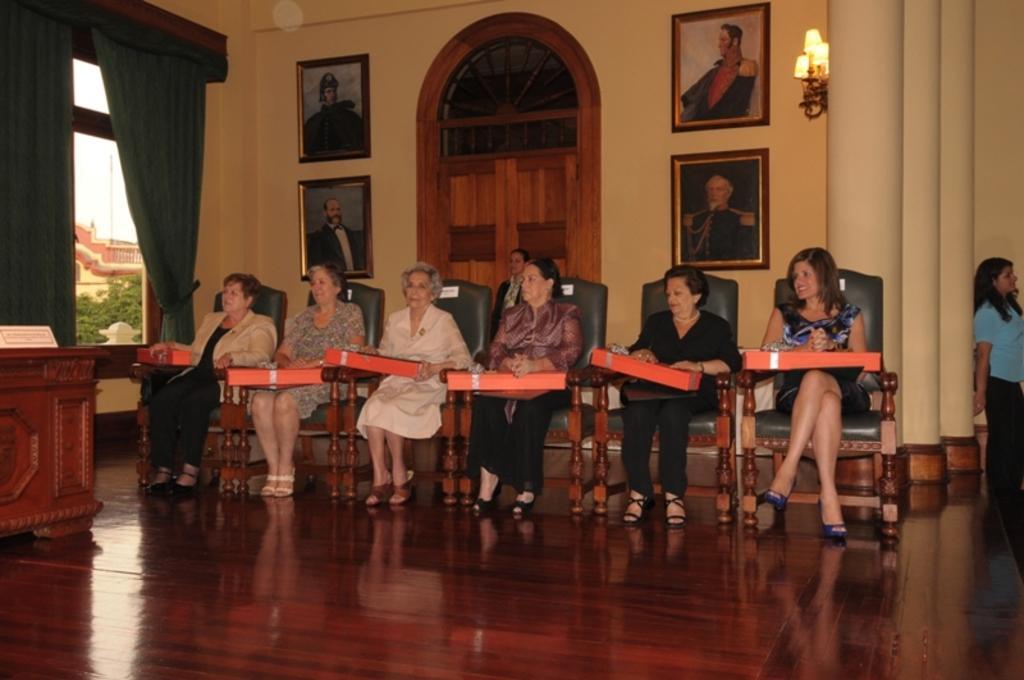Could you give a brief overview of what you see in this image? There are six women sitting on the chairs and all of them are holding red color boxes in their hands. Behind them, we see a white wall on which four photo frames are placed. Beside that, we see lights and pillars. On left corner of the picture, we see a window from which buildings and trees are visible. We even see curtains and table. This picture might be clicked inside the room. 